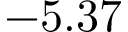Convert formula to latex. <formula><loc_0><loc_0><loc_500><loc_500>- 5 . 3 7</formula> 